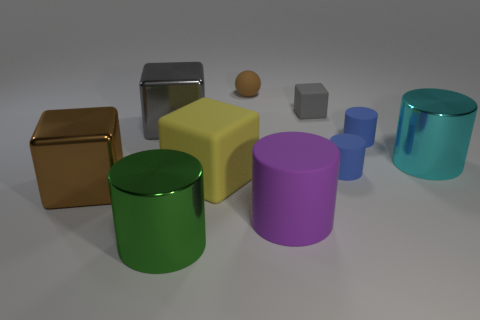Subtract all big gray metal cubes. How many cubes are left? 3 Subtract all brown blocks. How many blue cylinders are left? 2 Subtract all blue cylinders. How many cylinders are left? 3 Subtract 1 blocks. How many blocks are left? 3 Subtract all cyan cylinders. Subtract all green cubes. How many cylinders are left? 4 Subtract all blocks. How many objects are left? 6 Subtract 0 red blocks. How many objects are left? 10 Subtract all shiny cylinders. Subtract all tiny gray matte blocks. How many objects are left? 7 Add 3 cyan things. How many cyan things are left? 4 Add 5 big purple blocks. How many big purple blocks exist? 5 